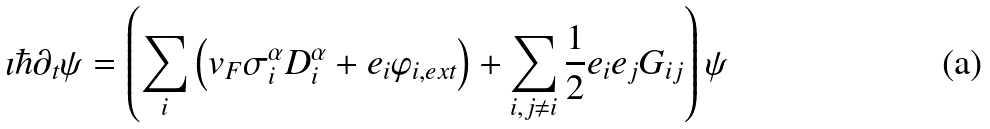<formula> <loc_0><loc_0><loc_500><loc_500>\imath \hbar { \partial } _ { t } \psi = \left ( \sum _ { i } \left ( v _ { F } \sigma ^ { \alpha } _ { i } D _ { i } ^ { \alpha } + e _ { i } \varphi _ { i , e x t } \right ) + \sum _ { i , j \neq i } \frac { 1 } { 2 } e _ { i } e _ { j } G _ { i j } \right ) \psi</formula> 